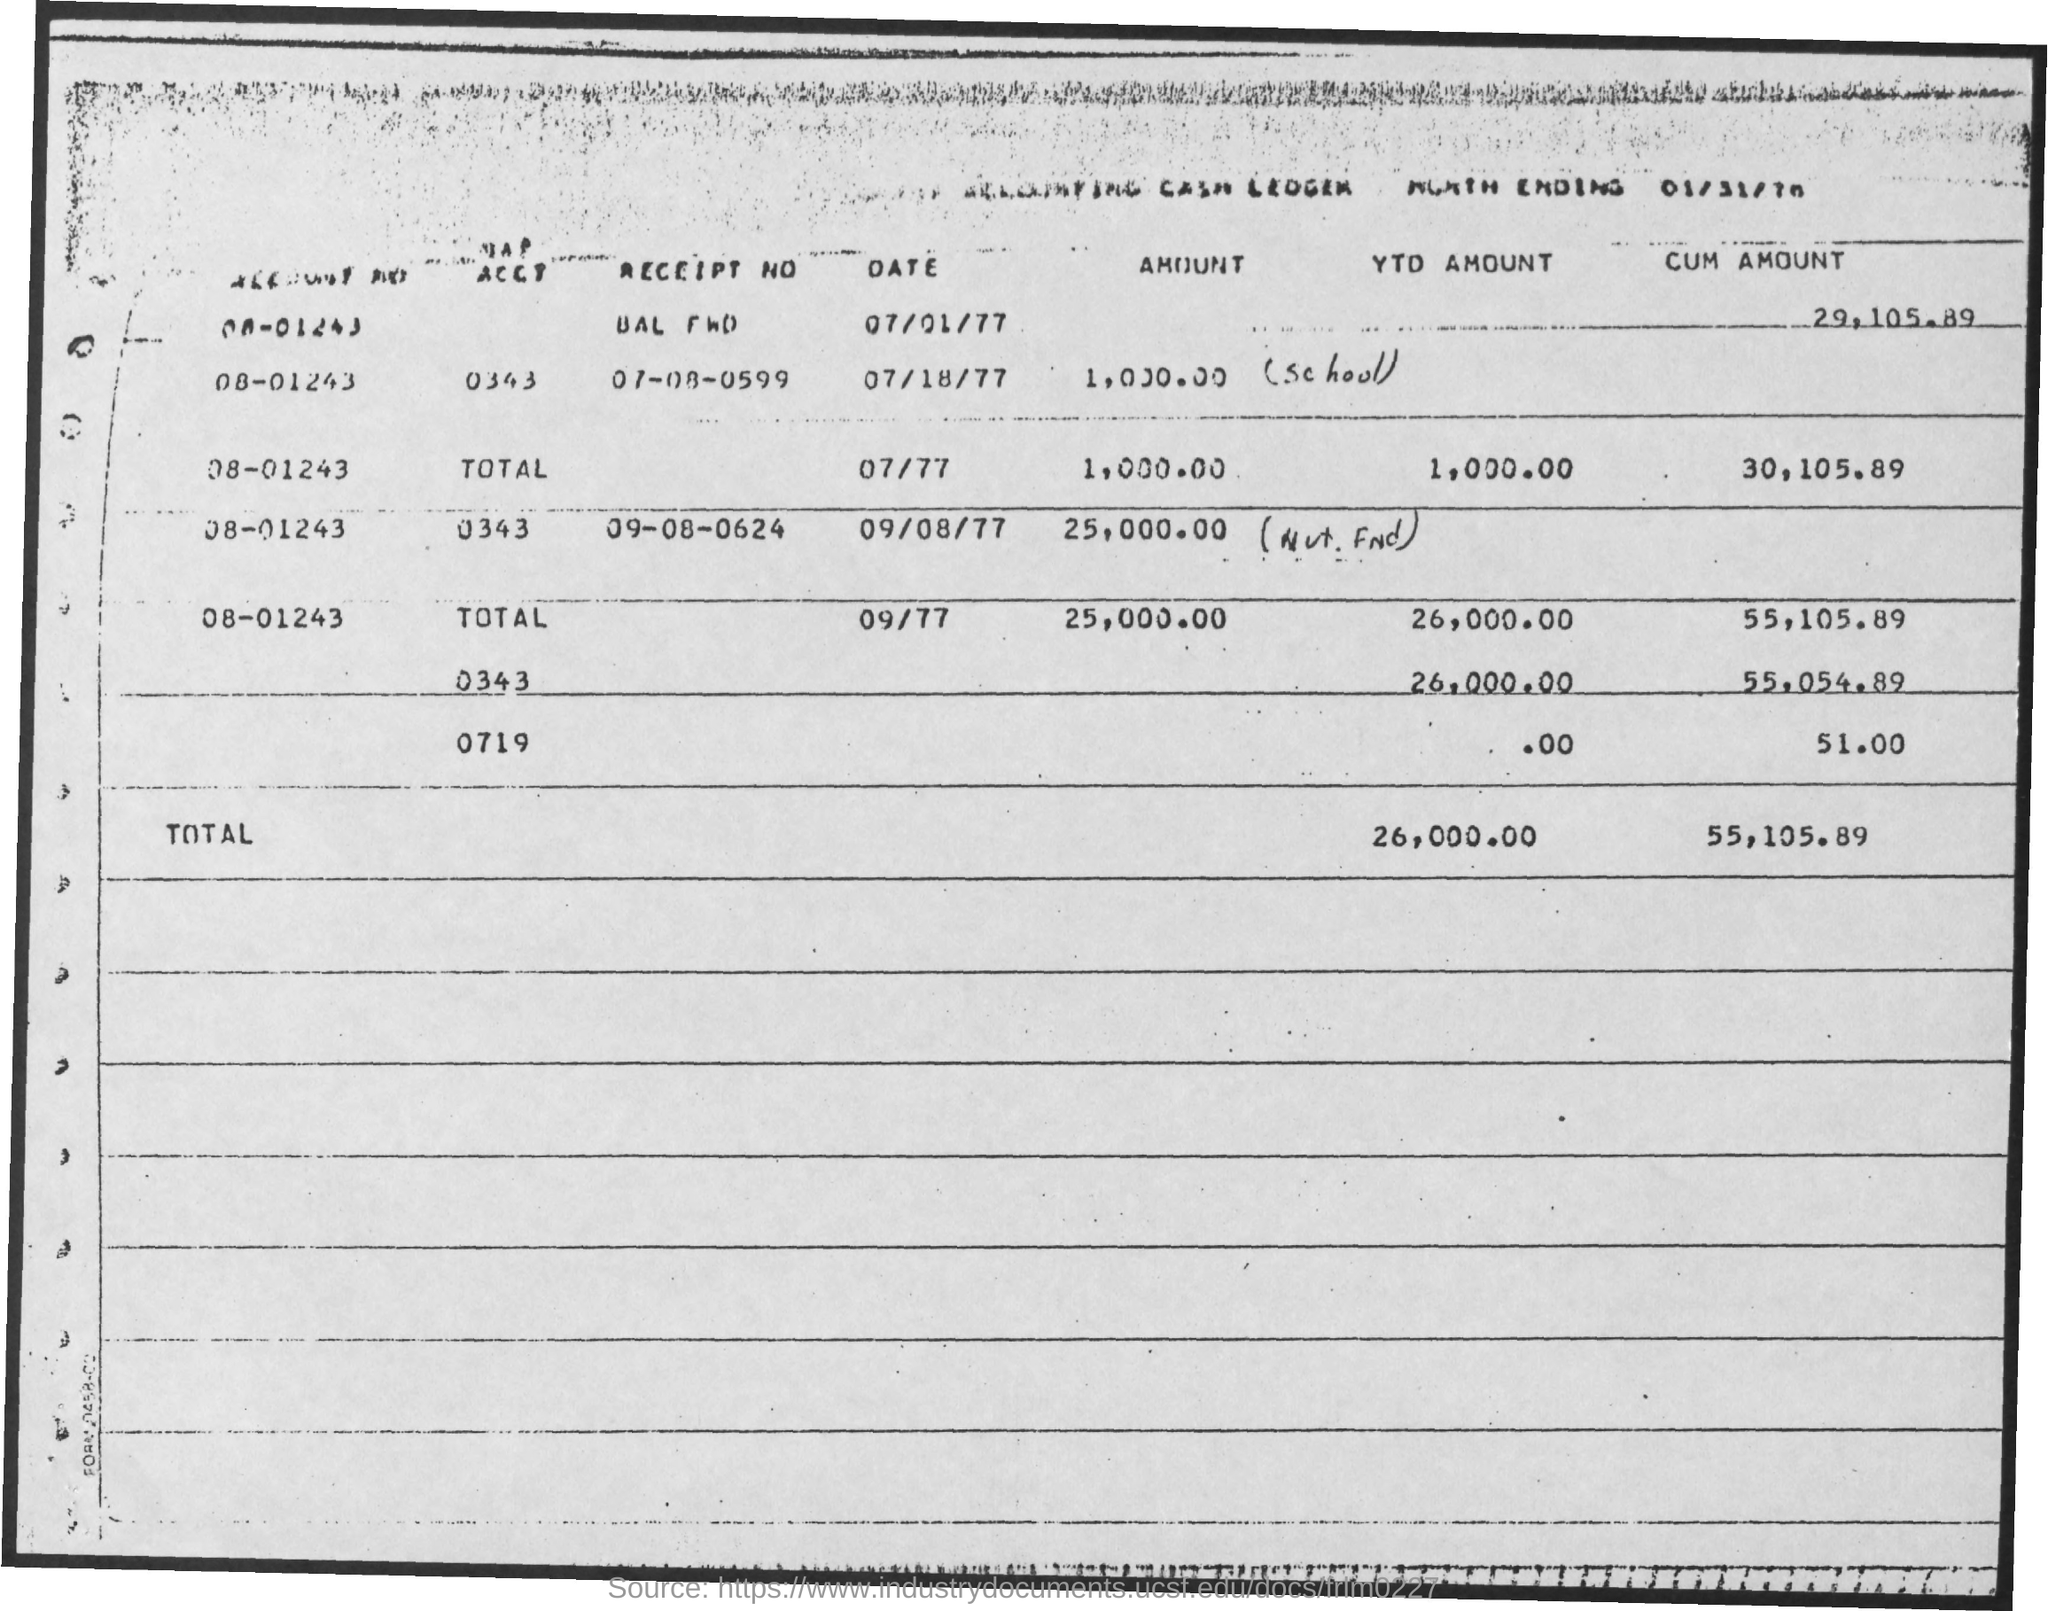Give some essential details in this illustration. The third account number listed in the table is 08-01243. 